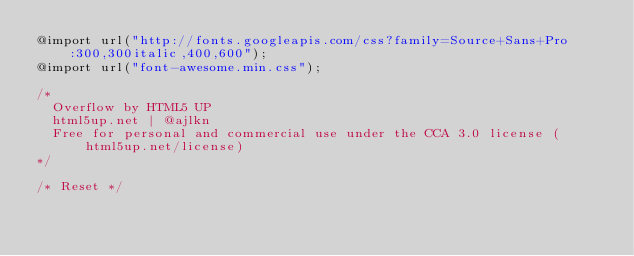Convert code to text. <code><loc_0><loc_0><loc_500><loc_500><_CSS_>@import url("http://fonts.googleapis.com/css?family=Source+Sans+Pro:300,300italic,400,600");
@import url("font-awesome.min.css");

/*
	Overflow by HTML5 UP
	html5up.net | @ajlkn
	Free for personal and commercial use under the CCA 3.0 license (html5up.net/license)
*/

/* Reset */
</code> 